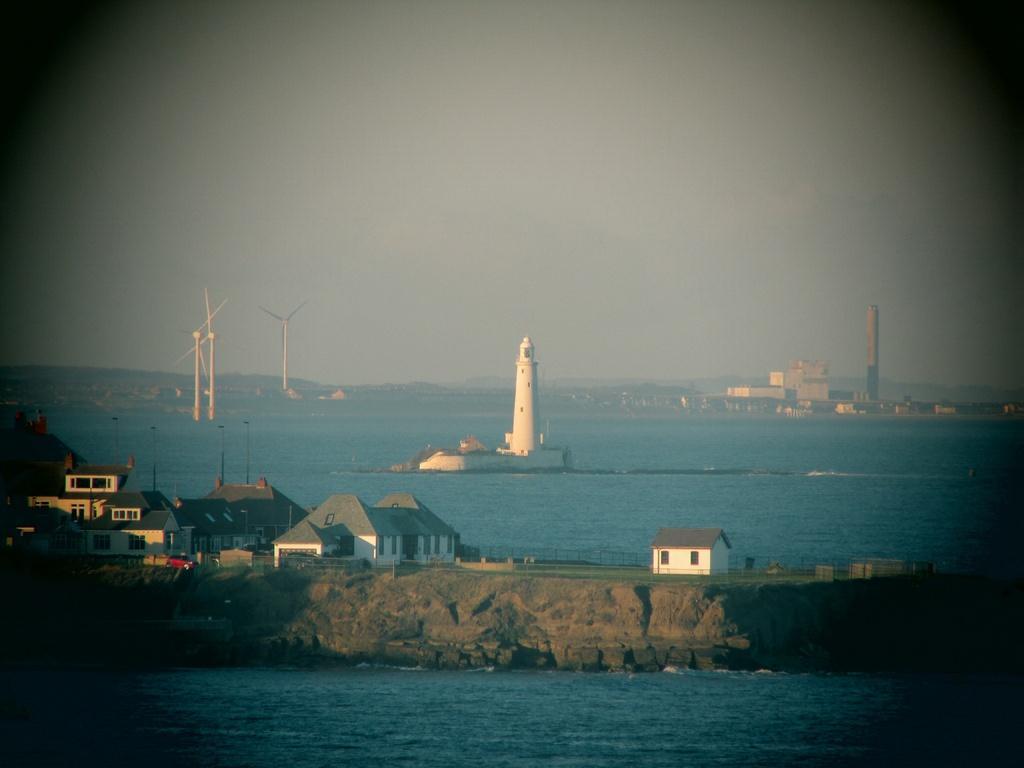Could you give a brief overview of what you see in this image? In this image there are some houses, tower, wind miles visible in the middle of the sea, there are some buildings visible in the middle, at the top there is the sky. 